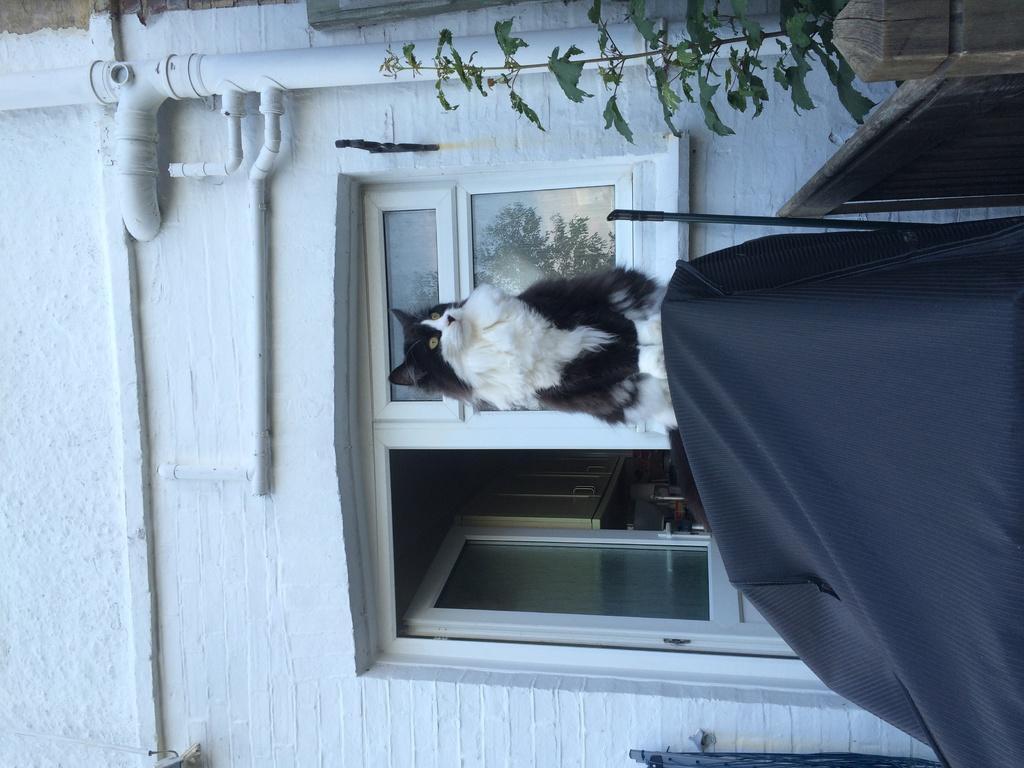Please provide a concise description of this image. In this image in the front there is an object which is black in colour. In the center there is a cat and there are windows and on the top there is a pipe and there is a plant and there is a wall which is white in colour. 